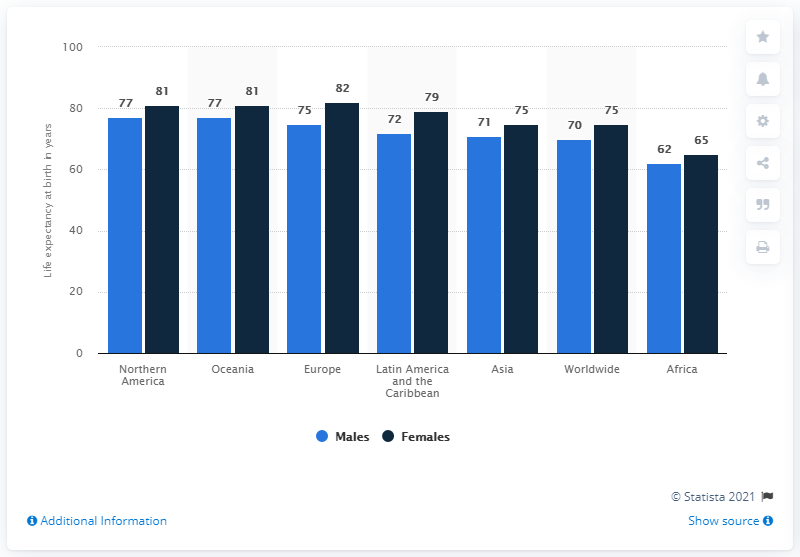List a handful of essential elements in this visual. The largest sum of the average life expectancy of both genders in a single continent is 158. The blue bars represent males. 